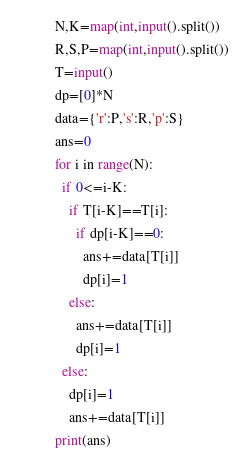<code> <loc_0><loc_0><loc_500><loc_500><_Python_>N,K=map(int,input().split())
R,S,P=map(int,input().split())
T=input()
dp=[0]*N
data={'r':P,'s':R,'p':S}
ans=0
for i in range(N):
  if 0<=i-K:
    if T[i-K]==T[i]:
      if dp[i-K]==0:
        ans+=data[T[i]]
        dp[i]=1
    else:
      ans+=data[T[i]]
      dp[i]=1
  else:
    dp[i]=1
    ans+=data[T[i]]
print(ans)</code> 